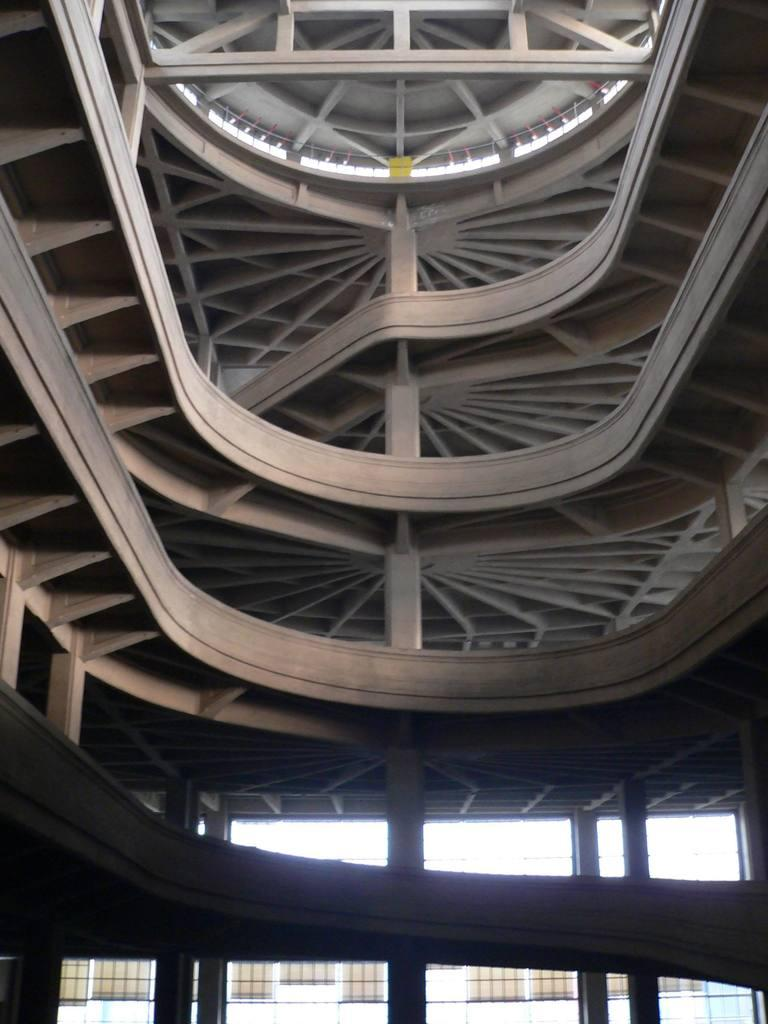What type of building is in the image? There is a ramp building in the image. What structural features can be seen on the ramp building? The ramp building has pillars. What type of glue is being used by the beggar in the image? There is no beggar present in the image, and therefore no glue can be observed. What industry is depicted in the image? The image does not depict any specific industry; it only shows a ramp building with pillars. 